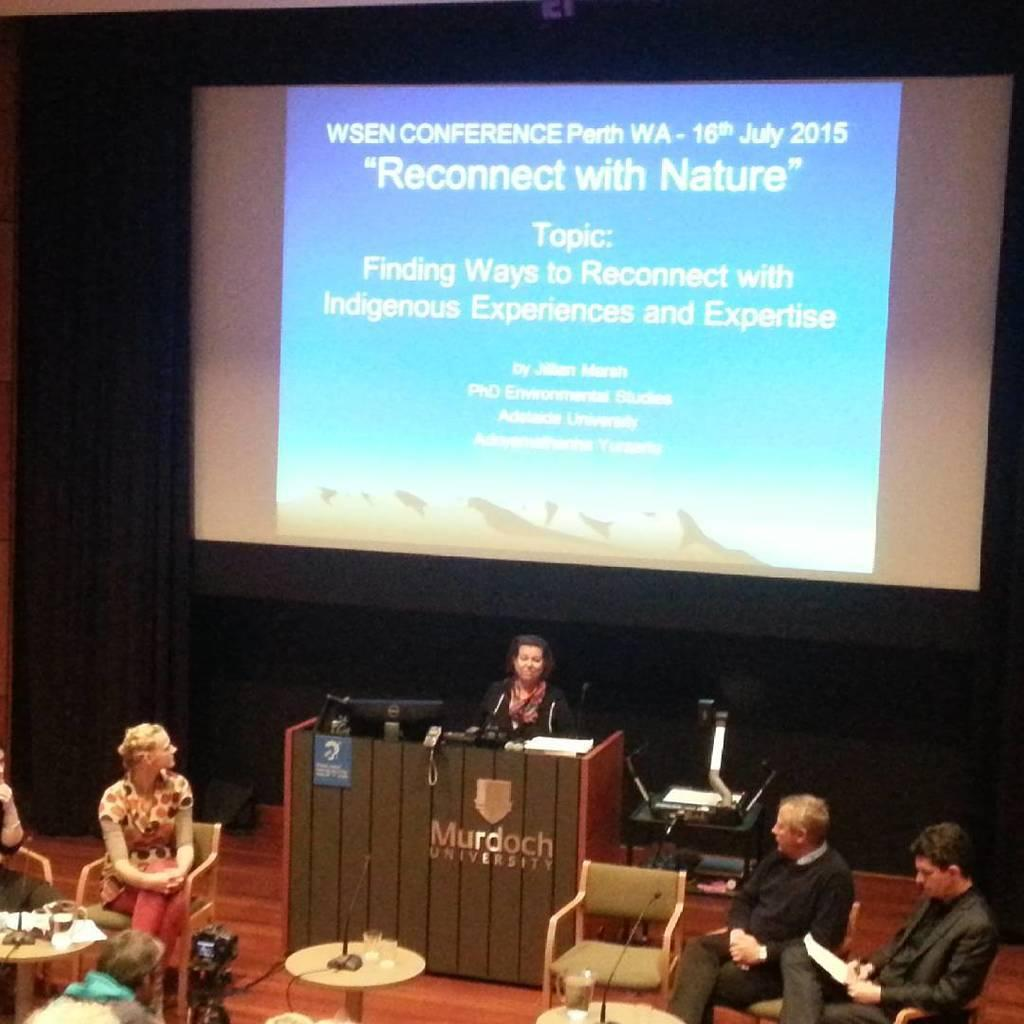How many people are in the image? There is a group of people in the image. What are the people in the image doing? The people are sitting and discussing. What can be seen in the background of the image? There is a projector screen in the background of the image. Can you see any ducks swimming in the image? There are no ducks present in the image. What type of marble is being used to play a game in the image? There is no game or marble present in the image. 